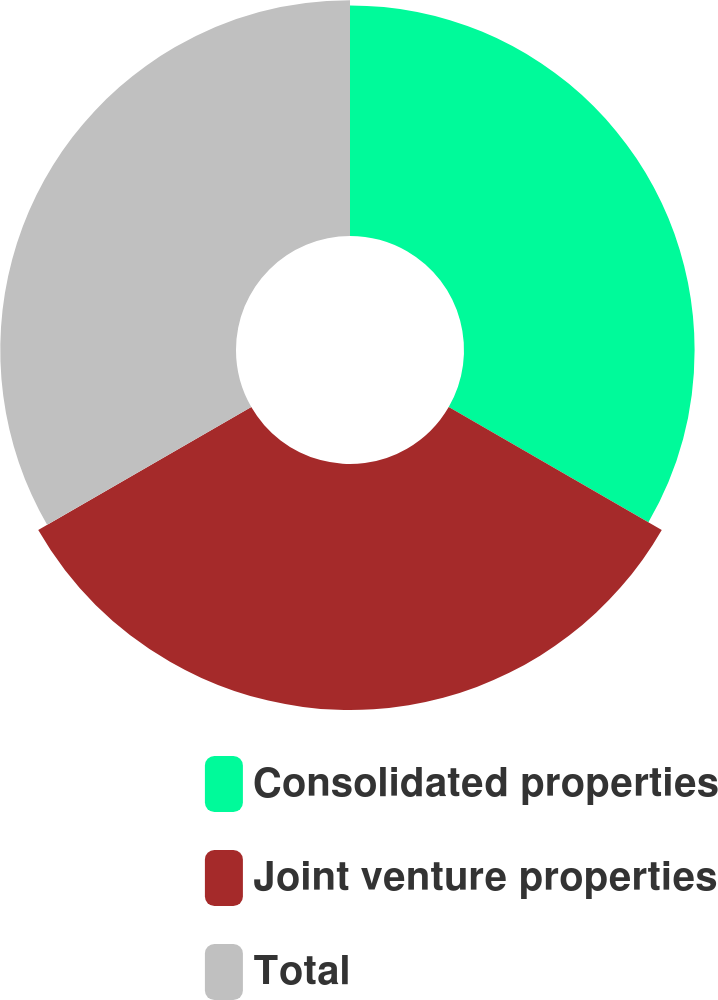Convert chart to OTSL. <chart><loc_0><loc_0><loc_500><loc_500><pie_chart><fcel>Consolidated properties<fcel>Joint venture properties<fcel>Total<nl><fcel>32.37%<fcel>34.53%<fcel>33.09%<nl></chart> 